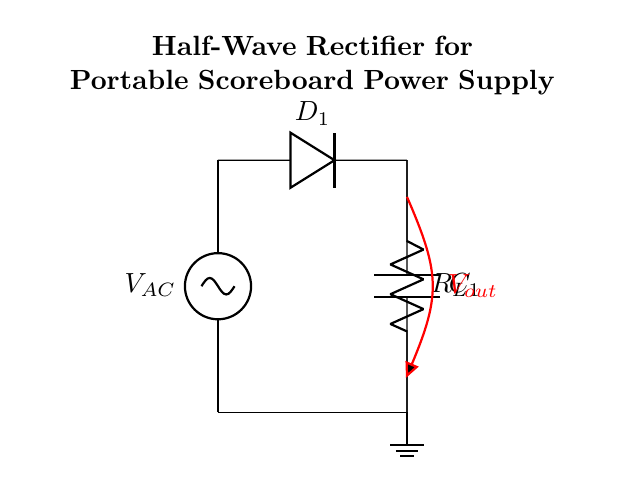What type of rectifier is shown in the diagram? The diagram illustrates a half-wave rectifier, which allows only one half of the AC voltage waveform to pass through while blocking the other half.
Answer: half-wave What is the purpose of the diode in this circuit? The diode's purpose is to conduct current in one direction only, effectively converting AC voltage into pulsating DC voltage by allowing only the positive half of the waveform to pass.
Answer: to conduct current in one direction What is the role of the capacitor in the circuit? The capacitor smooths out the pulsating DC output from the rectifier by charging during the positive half-cycles and discharging during the negative half-cycles, thus reducing voltage fluctuations.
Answer: to smooth the output voltage What is the value of the load resistor connected to the circuit? The value of the load resistor is not explicitly stated in the diagram. It's typically selected based on the required output voltage and current characteristics of the scoreboard.
Answer: not specified Which component determines the direction of current flow in this half-wave rectifier? The diode determines the direction of current flow, as it only allows current to flow when the input voltage is positive.
Answer: diode How does the load resistor affect the output voltage of the rectifier circuit? The load resistor affects the output voltage by creating a voltage drop determined by the current flowing through it; a higher resistance generally results in a lower output current and voltage.
Answer: voltage drop 